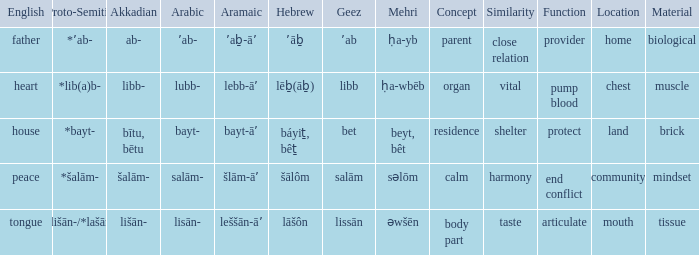What is the hebrew translation for the english word "heart"? Lēḇ(āḇ). 